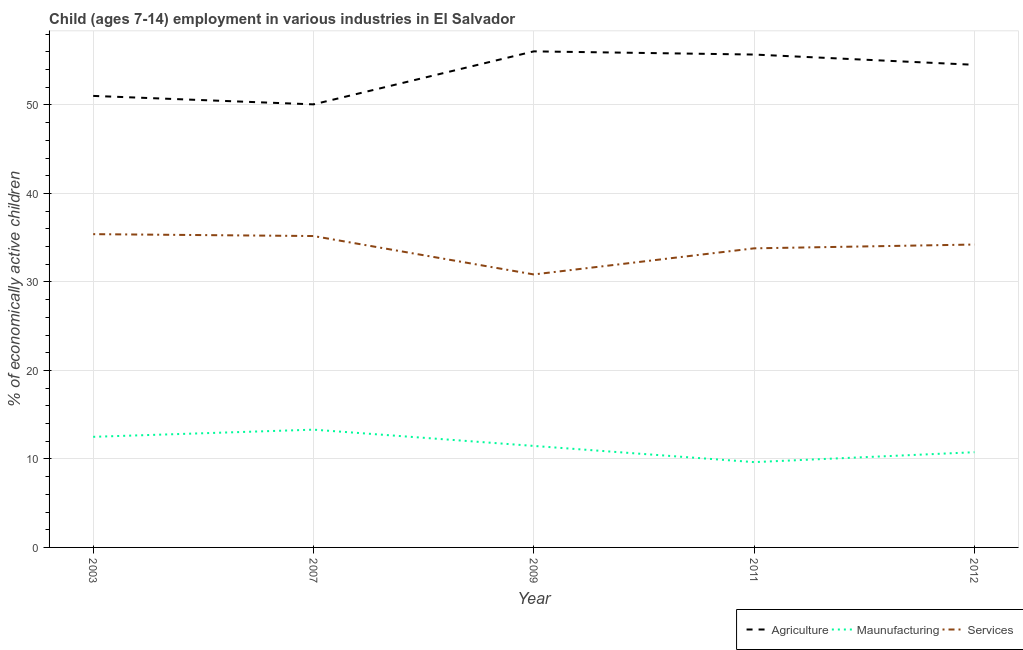Is the number of lines equal to the number of legend labels?
Provide a succinct answer. Yes. What is the percentage of economically active children in manufacturing in 2012?
Offer a terse response. 10.76. Across all years, what is the maximum percentage of economically active children in agriculture?
Keep it short and to the point. 56.06. Across all years, what is the minimum percentage of economically active children in agriculture?
Provide a succinct answer. 50.07. In which year was the percentage of economically active children in agriculture minimum?
Provide a succinct answer. 2007. What is the total percentage of economically active children in services in the graph?
Your answer should be compact. 169.47. What is the difference between the percentage of economically active children in manufacturing in 2007 and that in 2012?
Give a very brief answer. 2.55. What is the difference between the percentage of economically active children in services in 2007 and the percentage of economically active children in agriculture in 2011?
Offer a very short reply. -20.51. What is the average percentage of economically active children in agriculture per year?
Give a very brief answer. 53.48. In the year 2009, what is the difference between the percentage of economically active children in manufacturing and percentage of economically active children in services?
Make the answer very short. -19.38. What is the ratio of the percentage of economically active children in manufacturing in 2007 to that in 2011?
Ensure brevity in your answer.  1.38. Is the percentage of economically active children in services in 2003 less than that in 2009?
Ensure brevity in your answer.  No. Is the difference between the percentage of economically active children in agriculture in 2003 and 2009 greater than the difference between the percentage of economically active children in services in 2003 and 2009?
Your answer should be very brief. No. What is the difference between the highest and the second highest percentage of economically active children in services?
Give a very brief answer. 0.21. What is the difference between the highest and the lowest percentage of economically active children in services?
Your answer should be very brief. 4.55. Is the sum of the percentage of economically active children in agriculture in 2011 and 2012 greater than the maximum percentage of economically active children in manufacturing across all years?
Your response must be concise. Yes. How many lines are there?
Ensure brevity in your answer.  3. How many legend labels are there?
Make the answer very short. 3. What is the title of the graph?
Ensure brevity in your answer.  Child (ages 7-14) employment in various industries in El Salvador. Does "Secondary education" appear as one of the legend labels in the graph?
Offer a terse response. No. What is the label or title of the Y-axis?
Your answer should be compact. % of economically active children. What is the % of economically active children of Agriculture in 2003?
Your response must be concise. 51.03. What is the % of economically active children of Maunufacturing in 2003?
Offer a terse response. 12.5. What is the % of economically active children in Services in 2003?
Keep it short and to the point. 35.4. What is the % of economically active children of Agriculture in 2007?
Keep it short and to the point. 50.07. What is the % of economically active children in Maunufacturing in 2007?
Offer a terse response. 13.31. What is the % of economically active children in Services in 2007?
Offer a very short reply. 35.19. What is the % of economically active children in Agriculture in 2009?
Ensure brevity in your answer.  56.06. What is the % of economically active children in Maunufacturing in 2009?
Offer a terse response. 11.47. What is the % of economically active children of Services in 2009?
Offer a very short reply. 30.85. What is the % of economically active children of Agriculture in 2011?
Your answer should be very brief. 55.7. What is the % of economically active children of Maunufacturing in 2011?
Ensure brevity in your answer.  9.64. What is the % of economically active children of Services in 2011?
Your response must be concise. 33.8. What is the % of economically active children of Agriculture in 2012?
Keep it short and to the point. 54.54. What is the % of economically active children in Maunufacturing in 2012?
Offer a terse response. 10.76. What is the % of economically active children of Services in 2012?
Offer a terse response. 34.23. Across all years, what is the maximum % of economically active children in Agriculture?
Provide a short and direct response. 56.06. Across all years, what is the maximum % of economically active children of Maunufacturing?
Give a very brief answer. 13.31. Across all years, what is the maximum % of economically active children of Services?
Give a very brief answer. 35.4. Across all years, what is the minimum % of economically active children in Agriculture?
Keep it short and to the point. 50.07. Across all years, what is the minimum % of economically active children in Maunufacturing?
Keep it short and to the point. 9.64. Across all years, what is the minimum % of economically active children of Services?
Your answer should be very brief. 30.85. What is the total % of economically active children of Agriculture in the graph?
Provide a succinct answer. 267.4. What is the total % of economically active children in Maunufacturing in the graph?
Ensure brevity in your answer.  57.68. What is the total % of economically active children of Services in the graph?
Ensure brevity in your answer.  169.47. What is the difference between the % of economically active children of Agriculture in 2003 and that in 2007?
Your response must be concise. 0.96. What is the difference between the % of economically active children of Maunufacturing in 2003 and that in 2007?
Offer a terse response. -0.81. What is the difference between the % of economically active children of Services in 2003 and that in 2007?
Provide a short and direct response. 0.21. What is the difference between the % of economically active children of Agriculture in 2003 and that in 2009?
Your response must be concise. -5.03. What is the difference between the % of economically active children in Services in 2003 and that in 2009?
Your answer should be compact. 4.55. What is the difference between the % of economically active children in Agriculture in 2003 and that in 2011?
Ensure brevity in your answer.  -4.67. What is the difference between the % of economically active children of Maunufacturing in 2003 and that in 2011?
Your response must be concise. 2.86. What is the difference between the % of economically active children in Services in 2003 and that in 2011?
Provide a short and direct response. 1.6. What is the difference between the % of economically active children in Agriculture in 2003 and that in 2012?
Ensure brevity in your answer.  -3.51. What is the difference between the % of economically active children of Maunufacturing in 2003 and that in 2012?
Provide a succinct answer. 1.74. What is the difference between the % of economically active children of Services in 2003 and that in 2012?
Provide a short and direct response. 1.17. What is the difference between the % of economically active children in Agriculture in 2007 and that in 2009?
Your answer should be very brief. -5.99. What is the difference between the % of economically active children in Maunufacturing in 2007 and that in 2009?
Your answer should be compact. 1.84. What is the difference between the % of economically active children in Services in 2007 and that in 2009?
Provide a succinct answer. 4.34. What is the difference between the % of economically active children in Agriculture in 2007 and that in 2011?
Offer a very short reply. -5.63. What is the difference between the % of economically active children in Maunufacturing in 2007 and that in 2011?
Offer a terse response. 3.67. What is the difference between the % of economically active children in Services in 2007 and that in 2011?
Keep it short and to the point. 1.39. What is the difference between the % of economically active children of Agriculture in 2007 and that in 2012?
Ensure brevity in your answer.  -4.47. What is the difference between the % of economically active children in Maunufacturing in 2007 and that in 2012?
Ensure brevity in your answer.  2.55. What is the difference between the % of economically active children in Services in 2007 and that in 2012?
Your answer should be compact. 0.96. What is the difference between the % of economically active children in Agriculture in 2009 and that in 2011?
Ensure brevity in your answer.  0.36. What is the difference between the % of economically active children in Maunufacturing in 2009 and that in 2011?
Your response must be concise. 1.83. What is the difference between the % of economically active children in Services in 2009 and that in 2011?
Your response must be concise. -2.95. What is the difference between the % of economically active children of Agriculture in 2009 and that in 2012?
Keep it short and to the point. 1.52. What is the difference between the % of economically active children of Maunufacturing in 2009 and that in 2012?
Your response must be concise. 0.71. What is the difference between the % of economically active children of Services in 2009 and that in 2012?
Your answer should be compact. -3.38. What is the difference between the % of economically active children in Agriculture in 2011 and that in 2012?
Provide a succinct answer. 1.16. What is the difference between the % of economically active children in Maunufacturing in 2011 and that in 2012?
Your answer should be compact. -1.12. What is the difference between the % of economically active children in Services in 2011 and that in 2012?
Your response must be concise. -0.43. What is the difference between the % of economically active children in Agriculture in 2003 and the % of economically active children in Maunufacturing in 2007?
Give a very brief answer. 37.72. What is the difference between the % of economically active children of Agriculture in 2003 and the % of economically active children of Services in 2007?
Your answer should be compact. 15.84. What is the difference between the % of economically active children of Maunufacturing in 2003 and the % of economically active children of Services in 2007?
Make the answer very short. -22.69. What is the difference between the % of economically active children in Agriculture in 2003 and the % of economically active children in Maunufacturing in 2009?
Your response must be concise. 39.56. What is the difference between the % of economically active children of Agriculture in 2003 and the % of economically active children of Services in 2009?
Offer a very short reply. 20.18. What is the difference between the % of economically active children of Maunufacturing in 2003 and the % of economically active children of Services in 2009?
Your response must be concise. -18.35. What is the difference between the % of economically active children of Agriculture in 2003 and the % of economically active children of Maunufacturing in 2011?
Keep it short and to the point. 41.39. What is the difference between the % of economically active children of Agriculture in 2003 and the % of economically active children of Services in 2011?
Your response must be concise. 17.23. What is the difference between the % of economically active children in Maunufacturing in 2003 and the % of economically active children in Services in 2011?
Provide a short and direct response. -21.3. What is the difference between the % of economically active children in Agriculture in 2003 and the % of economically active children in Maunufacturing in 2012?
Give a very brief answer. 40.27. What is the difference between the % of economically active children in Agriculture in 2003 and the % of economically active children in Services in 2012?
Your response must be concise. 16.8. What is the difference between the % of economically active children in Maunufacturing in 2003 and the % of economically active children in Services in 2012?
Offer a terse response. -21.73. What is the difference between the % of economically active children in Agriculture in 2007 and the % of economically active children in Maunufacturing in 2009?
Keep it short and to the point. 38.6. What is the difference between the % of economically active children of Agriculture in 2007 and the % of economically active children of Services in 2009?
Your answer should be compact. 19.22. What is the difference between the % of economically active children in Maunufacturing in 2007 and the % of economically active children in Services in 2009?
Give a very brief answer. -17.54. What is the difference between the % of economically active children in Agriculture in 2007 and the % of economically active children in Maunufacturing in 2011?
Provide a short and direct response. 40.43. What is the difference between the % of economically active children in Agriculture in 2007 and the % of economically active children in Services in 2011?
Provide a short and direct response. 16.27. What is the difference between the % of economically active children of Maunufacturing in 2007 and the % of economically active children of Services in 2011?
Offer a terse response. -20.49. What is the difference between the % of economically active children in Agriculture in 2007 and the % of economically active children in Maunufacturing in 2012?
Provide a short and direct response. 39.31. What is the difference between the % of economically active children of Agriculture in 2007 and the % of economically active children of Services in 2012?
Give a very brief answer. 15.84. What is the difference between the % of economically active children of Maunufacturing in 2007 and the % of economically active children of Services in 2012?
Offer a terse response. -20.92. What is the difference between the % of economically active children of Agriculture in 2009 and the % of economically active children of Maunufacturing in 2011?
Make the answer very short. 46.42. What is the difference between the % of economically active children in Agriculture in 2009 and the % of economically active children in Services in 2011?
Offer a terse response. 22.26. What is the difference between the % of economically active children of Maunufacturing in 2009 and the % of economically active children of Services in 2011?
Your answer should be very brief. -22.33. What is the difference between the % of economically active children in Agriculture in 2009 and the % of economically active children in Maunufacturing in 2012?
Provide a succinct answer. 45.3. What is the difference between the % of economically active children of Agriculture in 2009 and the % of economically active children of Services in 2012?
Ensure brevity in your answer.  21.83. What is the difference between the % of economically active children of Maunufacturing in 2009 and the % of economically active children of Services in 2012?
Offer a very short reply. -22.76. What is the difference between the % of economically active children in Agriculture in 2011 and the % of economically active children in Maunufacturing in 2012?
Keep it short and to the point. 44.94. What is the difference between the % of economically active children of Agriculture in 2011 and the % of economically active children of Services in 2012?
Ensure brevity in your answer.  21.47. What is the difference between the % of economically active children of Maunufacturing in 2011 and the % of economically active children of Services in 2012?
Offer a terse response. -24.59. What is the average % of economically active children of Agriculture per year?
Offer a terse response. 53.48. What is the average % of economically active children of Maunufacturing per year?
Provide a short and direct response. 11.54. What is the average % of economically active children of Services per year?
Give a very brief answer. 33.89. In the year 2003, what is the difference between the % of economically active children of Agriculture and % of economically active children of Maunufacturing?
Provide a succinct answer. 38.53. In the year 2003, what is the difference between the % of economically active children in Agriculture and % of economically active children in Services?
Your answer should be very brief. 15.62. In the year 2003, what is the difference between the % of economically active children of Maunufacturing and % of economically active children of Services?
Offer a terse response. -22.9. In the year 2007, what is the difference between the % of economically active children of Agriculture and % of economically active children of Maunufacturing?
Your response must be concise. 36.76. In the year 2007, what is the difference between the % of economically active children of Agriculture and % of economically active children of Services?
Keep it short and to the point. 14.88. In the year 2007, what is the difference between the % of economically active children of Maunufacturing and % of economically active children of Services?
Your answer should be very brief. -21.88. In the year 2009, what is the difference between the % of economically active children of Agriculture and % of economically active children of Maunufacturing?
Provide a succinct answer. 44.59. In the year 2009, what is the difference between the % of economically active children in Agriculture and % of economically active children in Services?
Provide a short and direct response. 25.21. In the year 2009, what is the difference between the % of economically active children in Maunufacturing and % of economically active children in Services?
Your response must be concise. -19.38. In the year 2011, what is the difference between the % of economically active children of Agriculture and % of economically active children of Maunufacturing?
Offer a very short reply. 46.06. In the year 2011, what is the difference between the % of economically active children in Agriculture and % of economically active children in Services?
Make the answer very short. 21.9. In the year 2011, what is the difference between the % of economically active children of Maunufacturing and % of economically active children of Services?
Ensure brevity in your answer.  -24.16. In the year 2012, what is the difference between the % of economically active children in Agriculture and % of economically active children in Maunufacturing?
Offer a very short reply. 43.78. In the year 2012, what is the difference between the % of economically active children in Agriculture and % of economically active children in Services?
Give a very brief answer. 20.31. In the year 2012, what is the difference between the % of economically active children in Maunufacturing and % of economically active children in Services?
Give a very brief answer. -23.47. What is the ratio of the % of economically active children in Agriculture in 2003 to that in 2007?
Give a very brief answer. 1.02. What is the ratio of the % of economically active children in Maunufacturing in 2003 to that in 2007?
Your response must be concise. 0.94. What is the ratio of the % of economically active children of Services in 2003 to that in 2007?
Give a very brief answer. 1.01. What is the ratio of the % of economically active children of Agriculture in 2003 to that in 2009?
Give a very brief answer. 0.91. What is the ratio of the % of economically active children in Maunufacturing in 2003 to that in 2009?
Make the answer very short. 1.09. What is the ratio of the % of economically active children of Services in 2003 to that in 2009?
Give a very brief answer. 1.15. What is the ratio of the % of economically active children of Agriculture in 2003 to that in 2011?
Offer a very short reply. 0.92. What is the ratio of the % of economically active children in Maunufacturing in 2003 to that in 2011?
Your response must be concise. 1.3. What is the ratio of the % of economically active children of Services in 2003 to that in 2011?
Your answer should be compact. 1.05. What is the ratio of the % of economically active children in Agriculture in 2003 to that in 2012?
Your response must be concise. 0.94. What is the ratio of the % of economically active children in Maunufacturing in 2003 to that in 2012?
Offer a terse response. 1.16. What is the ratio of the % of economically active children of Services in 2003 to that in 2012?
Give a very brief answer. 1.03. What is the ratio of the % of economically active children in Agriculture in 2007 to that in 2009?
Make the answer very short. 0.89. What is the ratio of the % of economically active children of Maunufacturing in 2007 to that in 2009?
Provide a succinct answer. 1.16. What is the ratio of the % of economically active children of Services in 2007 to that in 2009?
Offer a very short reply. 1.14. What is the ratio of the % of economically active children in Agriculture in 2007 to that in 2011?
Keep it short and to the point. 0.9. What is the ratio of the % of economically active children in Maunufacturing in 2007 to that in 2011?
Give a very brief answer. 1.38. What is the ratio of the % of economically active children of Services in 2007 to that in 2011?
Provide a succinct answer. 1.04. What is the ratio of the % of economically active children in Agriculture in 2007 to that in 2012?
Offer a very short reply. 0.92. What is the ratio of the % of economically active children of Maunufacturing in 2007 to that in 2012?
Your answer should be very brief. 1.24. What is the ratio of the % of economically active children in Services in 2007 to that in 2012?
Provide a succinct answer. 1.03. What is the ratio of the % of economically active children of Agriculture in 2009 to that in 2011?
Make the answer very short. 1.01. What is the ratio of the % of economically active children of Maunufacturing in 2009 to that in 2011?
Offer a terse response. 1.19. What is the ratio of the % of economically active children of Services in 2009 to that in 2011?
Your answer should be very brief. 0.91. What is the ratio of the % of economically active children of Agriculture in 2009 to that in 2012?
Your response must be concise. 1.03. What is the ratio of the % of economically active children in Maunufacturing in 2009 to that in 2012?
Offer a terse response. 1.07. What is the ratio of the % of economically active children of Services in 2009 to that in 2012?
Provide a succinct answer. 0.9. What is the ratio of the % of economically active children in Agriculture in 2011 to that in 2012?
Your answer should be compact. 1.02. What is the ratio of the % of economically active children in Maunufacturing in 2011 to that in 2012?
Keep it short and to the point. 0.9. What is the ratio of the % of economically active children of Services in 2011 to that in 2012?
Provide a succinct answer. 0.99. What is the difference between the highest and the second highest % of economically active children in Agriculture?
Keep it short and to the point. 0.36. What is the difference between the highest and the second highest % of economically active children in Maunufacturing?
Provide a short and direct response. 0.81. What is the difference between the highest and the second highest % of economically active children in Services?
Your answer should be very brief. 0.21. What is the difference between the highest and the lowest % of economically active children in Agriculture?
Provide a succinct answer. 5.99. What is the difference between the highest and the lowest % of economically active children of Maunufacturing?
Offer a terse response. 3.67. What is the difference between the highest and the lowest % of economically active children of Services?
Provide a succinct answer. 4.55. 